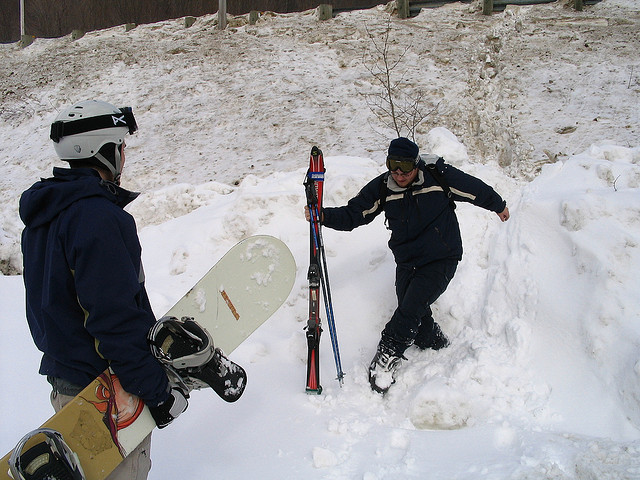<image>Which brand is the snowboard? It is unknown which brand the snowboard is. It can be adidas, forum, billabong, volcom, kelly or nike. Which brand is the snowboard? I don't know which brand is the snowboard. It can be 'and', 'adidas', 'none', 'unknown', 'forum', 'billabong', 'volcom', 'kelly', 'none', or 'nike'. 